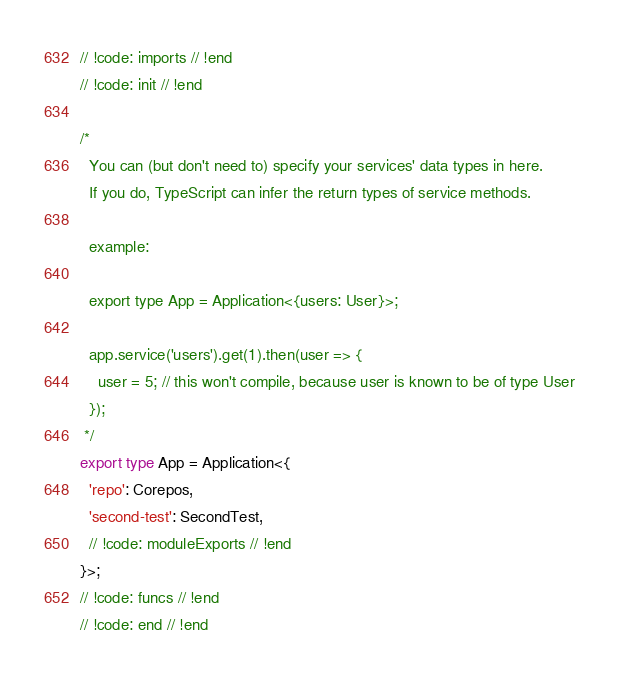<code> <loc_0><loc_0><loc_500><loc_500><_TypeScript_>// !code: imports // !end
// !code: init // !end

/*
  You can (but don't need to) specify your services' data types in here.
  If you do, TypeScript can infer the return types of service methods.

  example:

  export type App = Application<{users: User}>;

  app.service('users').get(1).then(user => {
    user = 5; // this won't compile, because user is known to be of type User
  });
 */
export type App = Application<{
  'repo': Corepos,
  'second-test': SecondTest,
  // !code: moduleExports // !end
}>;
// !code: funcs // !end
// !code: end // !end
</code> 